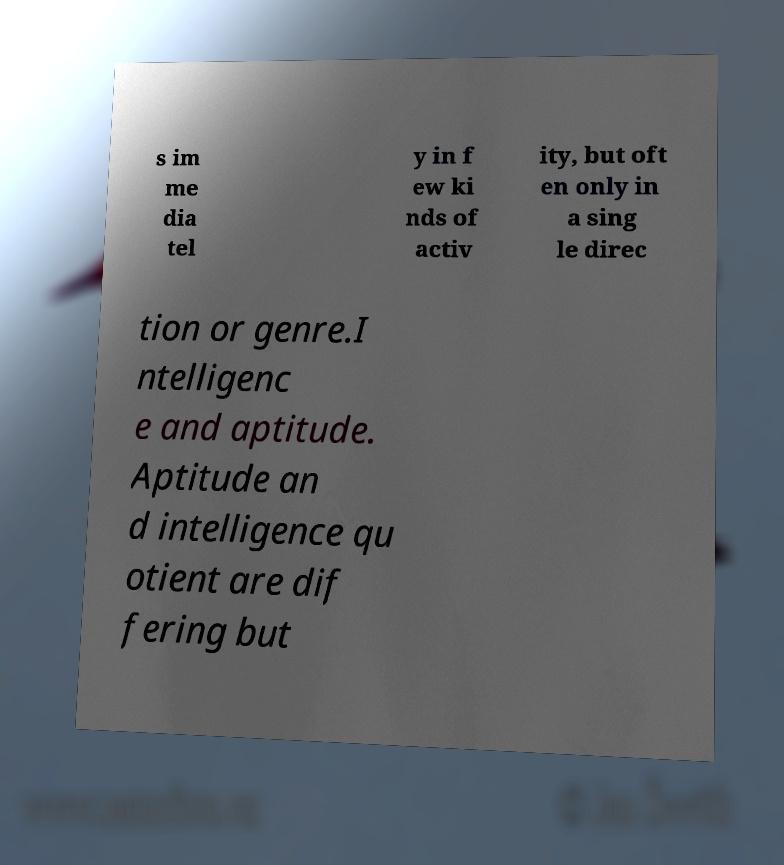Please read and relay the text visible in this image. What does it say? s im me dia tel y in f ew ki nds of activ ity, but oft en only in a sing le direc tion or genre.I ntelligenc e and aptitude. Aptitude an d intelligence qu otient are dif fering but 